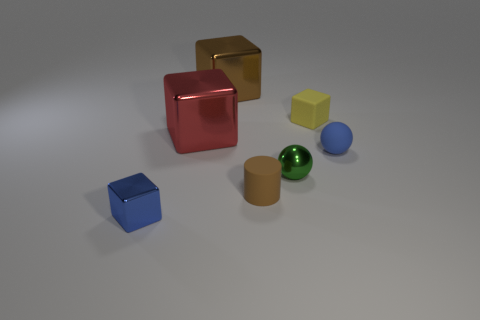Is there a red metallic thing of the same shape as the small blue metallic thing?
Keep it short and to the point. Yes. What color is the metal ball that is the same size as the yellow rubber thing?
Your answer should be very brief. Green. There is a small sphere to the left of the small matte block; what is its material?
Ensure brevity in your answer.  Metal. There is a blue thing that is behind the small shiny block; is its shape the same as the tiny metallic object right of the tiny blue metal thing?
Offer a very short reply. Yes. Are there the same number of small green metallic objects that are behind the green object and cylinders?
Ensure brevity in your answer.  No. How many green balls have the same material as the red object?
Give a very brief answer. 1. What color is the sphere that is made of the same material as the large brown object?
Your answer should be very brief. Green. There is a green sphere; is its size the same as the blue thing to the left of the small yellow matte block?
Offer a very short reply. Yes. The blue shiny object is what shape?
Make the answer very short. Cube. How many large shiny blocks have the same color as the metallic sphere?
Your answer should be compact. 0. 